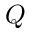Convert formula to latex. <formula><loc_0><loc_0><loc_500><loc_500>Q</formula> 